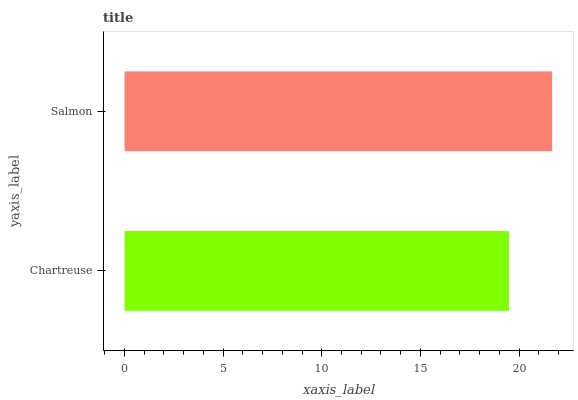Is Chartreuse the minimum?
Answer yes or no. Yes. Is Salmon the maximum?
Answer yes or no. Yes. Is Salmon the minimum?
Answer yes or no. No. Is Salmon greater than Chartreuse?
Answer yes or no. Yes. Is Chartreuse less than Salmon?
Answer yes or no. Yes. Is Chartreuse greater than Salmon?
Answer yes or no. No. Is Salmon less than Chartreuse?
Answer yes or no. No. Is Salmon the high median?
Answer yes or no. Yes. Is Chartreuse the low median?
Answer yes or no. Yes. Is Chartreuse the high median?
Answer yes or no. No. Is Salmon the low median?
Answer yes or no. No. 